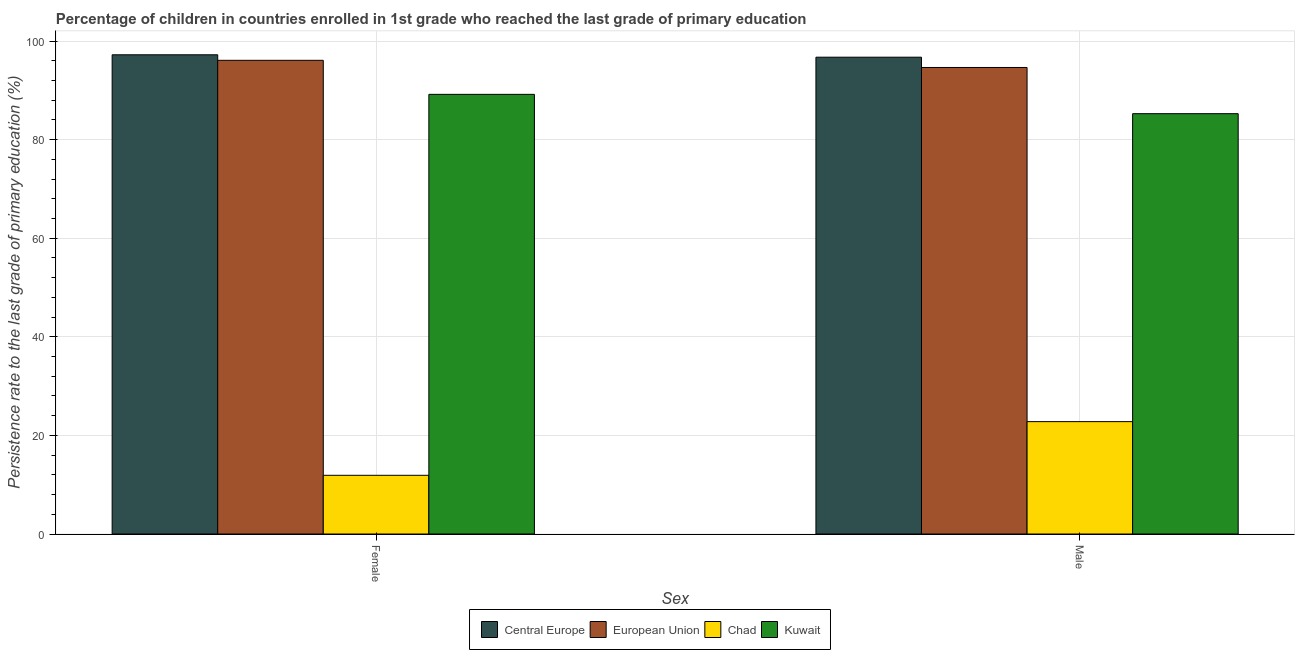How many different coloured bars are there?
Make the answer very short. 4. How many groups of bars are there?
Keep it short and to the point. 2. Are the number of bars per tick equal to the number of legend labels?
Your answer should be compact. Yes. Are the number of bars on each tick of the X-axis equal?
Make the answer very short. Yes. How many bars are there on the 2nd tick from the right?
Ensure brevity in your answer.  4. What is the label of the 2nd group of bars from the left?
Offer a terse response. Male. What is the persistence rate of male students in Central Europe?
Your response must be concise. 96.74. Across all countries, what is the maximum persistence rate of male students?
Offer a terse response. 96.74. Across all countries, what is the minimum persistence rate of male students?
Make the answer very short. 22.8. In which country was the persistence rate of female students maximum?
Provide a succinct answer. Central Europe. In which country was the persistence rate of female students minimum?
Make the answer very short. Chad. What is the total persistence rate of female students in the graph?
Make the answer very short. 294.44. What is the difference between the persistence rate of male students in Kuwait and that in Central Europe?
Your response must be concise. -11.46. What is the difference between the persistence rate of female students in Central Europe and the persistence rate of male students in Kuwait?
Offer a terse response. 11.95. What is the average persistence rate of male students per country?
Provide a short and direct response. 74.87. What is the difference between the persistence rate of female students and persistence rate of male students in European Union?
Provide a short and direct response. 1.45. What is the ratio of the persistence rate of female students in European Union to that in Kuwait?
Keep it short and to the point. 1.08. What does the 1st bar from the left in Female represents?
Ensure brevity in your answer.  Central Europe. What does the 2nd bar from the right in Female represents?
Offer a terse response. Chad. How many bars are there?
Provide a short and direct response. 8. How many countries are there in the graph?
Give a very brief answer. 4. What is the difference between two consecutive major ticks on the Y-axis?
Your answer should be very brief. 20. Where does the legend appear in the graph?
Provide a short and direct response. Bottom center. How many legend labels are there?
Offer a very short reply. 4. How are the legend labels stacked?
Provide a succinct answer. Horizontal. What is the title of the graph?
Make the answer very short. Percentage of children in countries enrolled in 1st grade who reached the last grade of primary education. What is the label or title of the X-axis?
Your answer should be very brief. Sex. What is the label or title of the Y-axis?
Your answer should be compact. Persistence rate to the last grade of primary education (%). What is the Persistence rate to the last grade of primary education (%) of Central Europe in Female?
Offer a very short reply. 97.23. What is the Persistence rate to the last grade of primary education (%) in European Union in Female?
Your answer should be compact. 96.11. What is the Persistence rate to the last grade of primary education (%) in Chad in Female?
Offer a terse response. 11.91. What is the Persistence rate to the last grade of primary education (%) of Kuwait in Female?
Your response must be concise. 89.2. What is the Persistence rate to the last grade of primary education (%) of Central Europe in Male?
Your response must be concise. 96.74. What is the Persistence rate to the last grade of primary education (%) in European Union in Male?
Keep it short and to the point. 94.65. What is the Persistence rate to the last grade of primary education (%) of Chad in Male?
Offer a very short reply. 22.8. What is the Persistence rate to the last grade of primary education (%) in Kuwait in Male?
Provide a short and direct response. 85.28. Across all Sex, what is the maximum Persistence rate to the last grade of primary education (%) of Central Europe?
Make the answer very short. 97.23. Across all Sex, what is the maximum Persistence rate to the last grade of primary education (%) of European Union?
Offer a very short reply. 96.11. Across all Sex, what is the maximum Persistence rate to the last grade of primary education (%) in Chad?
Offer a very short reply. 22.8. Across all Sex, what is the maximum Persistence rate to the last grade of primary education (%) of Kuwait?
Your answer should be compact. 89.2. Across all Sex, what is the minimum Persistence rate to the last grade of primary education (%) of Central Europe?
Give a very brief answer. 96.74. Across all Sex, what is the minimum Persistence rate to the last grade of primary education (%) of European Union?
Offer a terse response. 94.65. Across all Sex, what is the minimum Persistence rate to the last grade of primary education (%) of Chad?
Offer a terse response. 11.91. Across all Sex, what is the minimum Persistence rate to the last grade of primary education (%) of Kuwait?
Your answer should be compact. 85.28. What is the total Persistence rate to the last grade of primary education (%) in Central Europe in the graph?
Make the answer very short. 193.97. What is the total Persistence rate to the last grade of primary education (%) in European Union in the graph?
Provide a succinct answer. 190.76. What is the total Persistence rate to the last grade of primary education (%) in Chad in the graph?
Offer a very short reply. 34.71. What is the total Persistence rate to the last grade of primary education (%) in Kuwait in the graph?
Provide a succinct answer. 174.48. What is the difference between the Persistence rate to the last grade of primary education (%) in Central Europe in Female and that in Male?
Make the answer very short. 0.49. What is the difference between the Persistence rate to the last grade of primary education (%) in European Union in Female and that in Male?
Your response must be concise. 1.45. What is the difference between the Persistence rate to the last grade of primary education (%) of Chad in Female and that in Male?
Your answer should be very brief. -10.89. What is the difference between the Persistence rate to the last grade of primary education (%) in Kuwait in Female and that in Male?
Your response must be concise. 3.92. What is the difference between the Persistence rate to the last grade of primary education (%) in Central Europe in Female and the Persistence rate to the last grade of primary education (%) in European Union in Male?
Offer a very short reply. 2.58. What is the difference between the Persistence rate to the last grade of primary education (%) in Central Europe in Female and the Persistence rate to the last grade of primary education (%) in Chad in Male?
Give a very brief answer. 74.43. What is the difference between the Persistence rate to the last grade of primary education (%) in Central Europe in Female and the Persistence rate to the last grade of primary education (%) in Kuwait in Male?
Keep it short and to the point. 11.95. What is the difference between the Persistence rate to the last grade of primary education (%) in European Union in Female and the Persistence rate to the last grade of primary education (%) in Chad in Male?
Keep it short and to the point. 73.31. What is the difference between the Persistence rate to the last grade of primary education (%) of European Union in Female and the Persistence rate to the last grade of primary education (%) of Kuwait in Male?
Ensure brevity in your answer.  10.83. What is the difference between the Persistence rate to the last grade of primary education (%) in Chad in Female and the Persistence rate to the last grade of primary education (%) in Kuwait in Male?
Provide a succinct answer. -73.37. What is the average Persistence rate to the last grade of primary education (%) of Central Europe per Sex?
Keep it short and to the point. 96.98. What is the average Persistence rate to the last grade of primary education (%) of European Union per Sex?
Provide a short and direct response. 95.38. What is the average Persistence rate to the last grade of primary education (%) of Chad per Sex?
Make the answer very short. 17.35. What is the average Persistence rate to the last grade of primary education (%) of Kuwait per Sex?
Make the answer very short. 87.24. What is the difference between the Persistence rate to the last grade of primary education (%) in Central Europe and Persistence rate to the last grade of primary education (%) in European Union in Female?
Your response must be concise. 1.12. What is the difference between the Persistence rate to the last grade of primary education (%) of Central Europe and Persistence rate to the last grade of primary education (%) of Chad in Female?
Your answer should be very brief. 85.32. What is the difference between the Persistence rate to the last grade of primary education (%) in Central Europe and Persistence rate to the last grade of primary education (%) in Kuwait in Female?
Your response must be concise. 8.03. What is the difference between the Persistence rate to the last grade of primary education (%) in European Union and Persistence rate to the last grade of primary education (%) in Chad in Female?
Ensure brevity in your answer.  84.2. What is the difference between the Persistence rate to the last grade of primary education (%) of European Union and Persistence rate to the last grade of primary education (%) of Kuwait in Female?
Keep it short and to the point. 6.91. What is the difference between the Persistence rate to the last grade of primary education (%) in Chad and Persistence rate to the last grade of primary education (%) in Kuwait in Female?
Ensure brevity in your answer.  -77.29. What is the difference between the Persistence rate to the last grade of primary education (%) in Central Europe and Persistence rate to the last grade of primary education (%) in European Union in Male?
Provide a succinct answer. 2.09. What is the difference between the Persistence rate to the last grade of primary education (%) in Central Europe and Persistence rate to the last grade of primary education (%) in Chad in Male?
Make the answer very short. 73.94. What is the difference between the Persistence rate to the last grade of primary education (%) in Central Europe and Persistence rate to the last grade of primary education (%) in Kuwait in Male?
Ensure brevity in your answer.  11.46. What is the difference between the Persistence rate to the last grade of primary education (%) in European Union and Persistence rate to the last grade of primary education (%) in Chad in Male?
Keep it short and to the point. 71.85. What is the difference between the Persistence rate to the last grade of primary education (%) of European Union and Persistence rate to the last grade of primary education (%) of Kuwait in Male?
Offer a terse response. 9.37. What is the difference between the Persistence rate to the last grade of primary education (%) in Chad and Persistence rate to the last grade of primary education (%) in Kuwait in Male?
Give a very brief answer. -62.48. What is the ratio of the Persistence rate to the last grade of primary education (%) in European Union in Female to that in Male?
Provide a short and direct response. 1.02. What is the ratio of the Persistence rate to the last grade of primary education (%) in Chad in Female to that in Male?
Provide a succinct answer. 0.52. What is the ratio of the Persistence rate to the last grade of primary education (%) of Kuwait in Female to that in Male?
Offer a terse response. 1.05. What is the difference between the highest and the second highest Persistence rate to the last grade of primary education (%) in Central Europe?
Provide a short and direct response. 0.49. What is the difference between the highest and the second highest Persistence rate to the last grade of primary education (%) of European Union?
Your response must be concise. 1.45. What is the difference between the highest and the second highest Persistence rate to the last grade of primary education (%) in Chad?
Give a very brief answer. 10.89. What is the difference between the highest and the second highest Persistence rate to the last grade of primary education (%) in Kuwait?
Give a very brief answer. 3.92. What is the difference between the highest and the lowest Persistence rate to the last grade of primary education (%) of Central Europe?
Offer a very short reply. 0.49. What is the difference between the highest and the lowest Persistence rate to the last grade of primary education (%) in European Union?
Give a very brief answer. 1.45. What is the difference between the highest and the lowest Persistence rate to the last grade of primary education (%) of Chad?
Provide a succinct answer. 10.89. What is the difference between the highest and the lowest Persistence rate to the last grade of primary education (%) in Kuwait?
Provide a short and direct response. 3.92. 